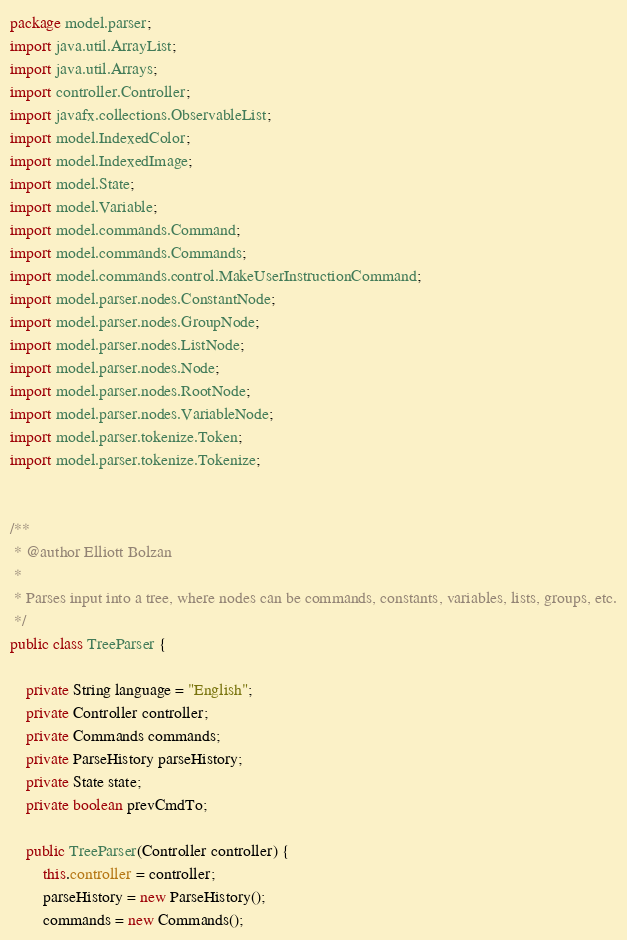Convert code to text. <code><loc_0><loc_0><loc_500><loc_500><_Java_>package model.parser;
import java.util.ArrayList;
import java.util.Arrays;
import controller.Controller;
import javafx.collections.ObservableList;
import model.IndexedColor;
import model.IndexedImage;
import model.State;
import model.Variable;
import model.commands.Command;
import model.commands.Commands;
import model.commands.control.MakeUserInstructionCommand;
import model.parser.nodes.ConstantNode;
import model.parser.nodes.GroupNode;
import model.parser.nodes.ListNode;
import model.parser.nodes.Node;
import model.parser.nodes.RootNode;
import model.parser.nodes.VariableNode;
import model.parser.tokenize.Token;
import model.parser.tokenize.Tokenize;


/**
 * @author Elliott Bolzan
 *
 * Parses input into a tree, where nodes can be commands, constants, variables, lists, groups, etc.
 */
public class TreeParser {

	private String language = "English";
	private Controller controller;
	private Commands commands;
	private ParseHistory parseHistory;
	private State state;
	private boolean prevCmdTo;

	public TreeParser(Controller controller) {
		this.controller = controller;
		parseHistory = new ParseHistory();
		commands = new Commands();</code> 